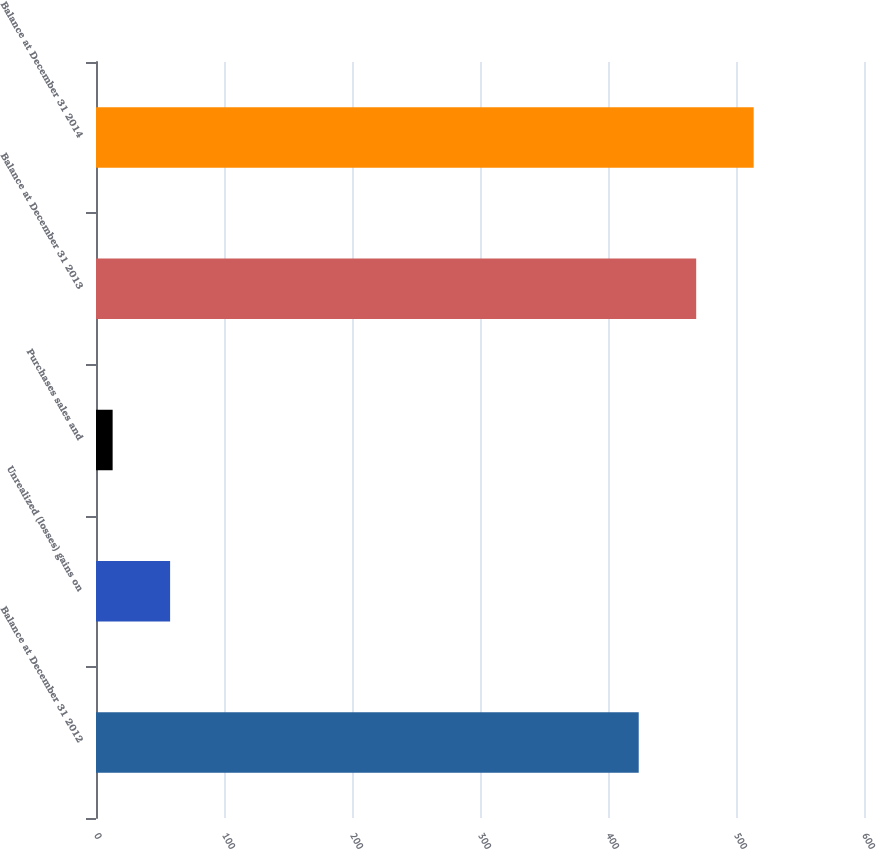<chart> <loc_0><loc_0><loc_500><loc_500><bar_chart><fcel>Balance at December 31 2012<fcel>Unrealized (losses) gains on<fcel>Purchases sales and<fcel>Balance at December 31 2013<fcel>Balance at December 31 2014<nl><fcel>424<fcel>57.9<fcel>13<fcel>468.9<fcel>513.8<nl></chart> 